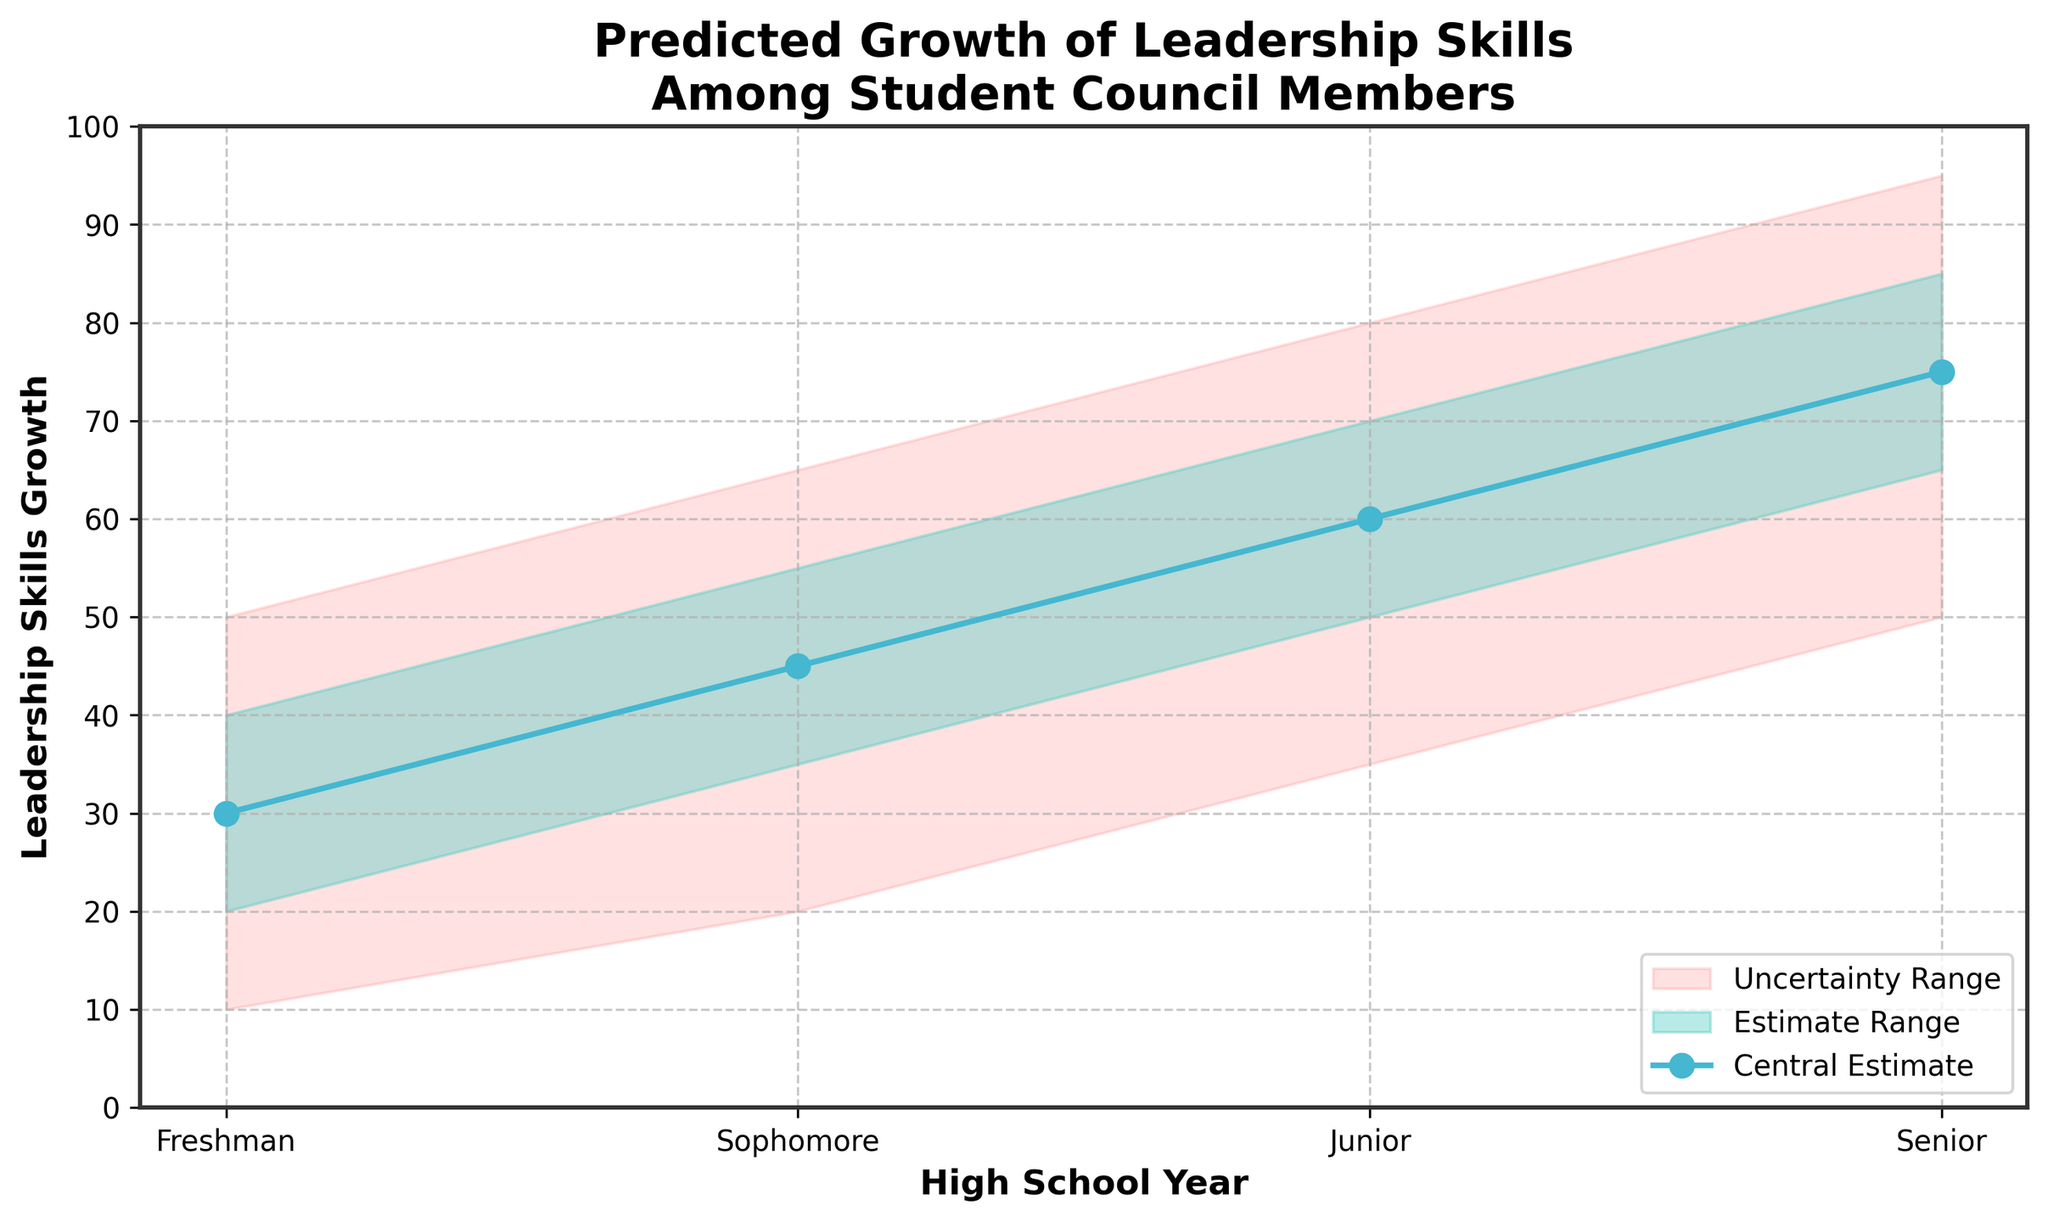What's the title of the figure? The title is displayed at the top of the figure, summarizing the content of the chart in a few words.
Answer: Predicted Growth of Leadership Skills Among Student Council Members What are the years included in the chart? The years are listed along the x-axis, representing each high school year for the prediction. They are in sequential order from left to right.
Answer: Freshman, Sophomore, Junior, Senior What is the highest value shown on the y-axis? The y-axis values are labeled with tick marks, the highest number shown indicates the maximum value represented in the chart.
Answer: 100 How is the Central Estimate visually represented? The central estimate is typically highlighted using a distinct line and markers. In this chart, it's depicted by a specific color line with data points.
Answer: A solid blue line with circular markers What is the range of the Central Estimate for Senior year? To find the range, locate the senior year and note the lower and upper limits of the central estimate.
Answer: 75 How does the range of the Uncertainty Range change from Freshman to Senior year? Compare the lower and upper bounds for each year. Notice if the range widens or narrows throughout the years.
Answer: The range widens from Freshman to Senior year How much does the Central Estimate grow from Freshman to Sophomore year? Subtract the Central Estimate value of Freshman year from that of Sophomore year.
Answer: 15 units Which year shows the most significant predicted growth in leadership skills according to the Central Estimate? Find the year with the highest value in the Central Estimate, as shown by the blue line.
Answer: Senior year How does the Estimate Range (green shaded area) change over the years? Observe the width and positioning of the green shaded area between the lower and upper estimates across each year.
Answer: It increases from Freshman to Senior year In which year is the Uncertainty Range the narrowest? Look at the width of the pink shaded area between the lower bound and upper bound for each year.
Answer: Freshman year 